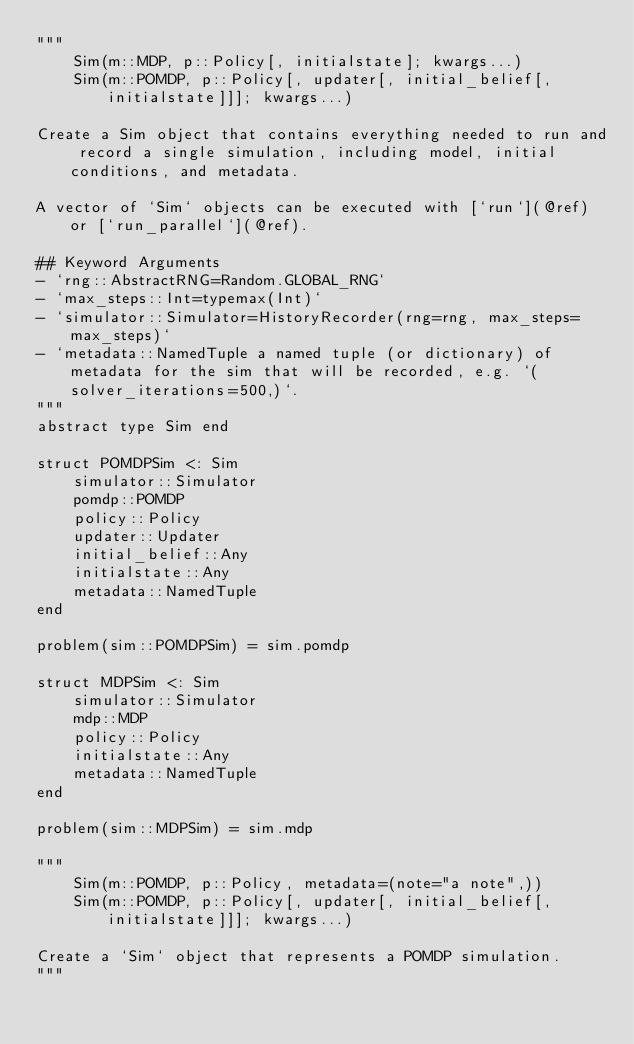Convert code to text. <code><loc_0><loc_0><loc_500><loc_500><_Julia_>"""
    Sim(m::MDP, p::Policy[, initialstate]; kwargs...)
    Sim(m::POMDP, p::Policy[, updater[, initial_belief[, initialstate]]]; kwargs...)

Create a Sim object that contains everything needed to run and record a single simulation, including model, initial conditions, and metadata.

A vector of `Sim` objects can be executed with [`run`](@ref) or [`run_parallel`](@ref).

## Keyword Arguments
- `rng::AbstractRNG=Random.GLOBAL_RNG`
- `max_steps::Int=typemax(Int)`
- `simulator::Simulator=HistoryRecorder(rng=rng, max_steps=max_steps)`
- `metadata::NamedTuple a named tuple (or dictionary) of metadata for the sim that will be recorded, e.g. `(solver_iterations=500,)`.
"""
abstract type Sim end

struct POMDPSim <: Sim
    simulator::Simulator
    pomdp::POMDP
    policy::Policy
    updater::Updater
    initial_belief::Any
    initialstate::Any
    metadata::NamedTuple
end

problem(sim::POMDPSim) = sim.pomdp

struct MDPSim <: Sim
    simulator::Simulator
    mdp::MDP
    policy::Policy
    initialstate::Any
    metadata::NamedTuple
end

problem(sim::MDPSim) = sim.mdp

"""
    Sim(m::POMDP, p::Policy, metadata=(note="a note",))
    Sim(m::POMDP, p::Policy[, updater[, initial_belief[, initialstate]]]; kwargs...)

Create a `Sim` object that represents a POMDP simulation.
"""</code> 